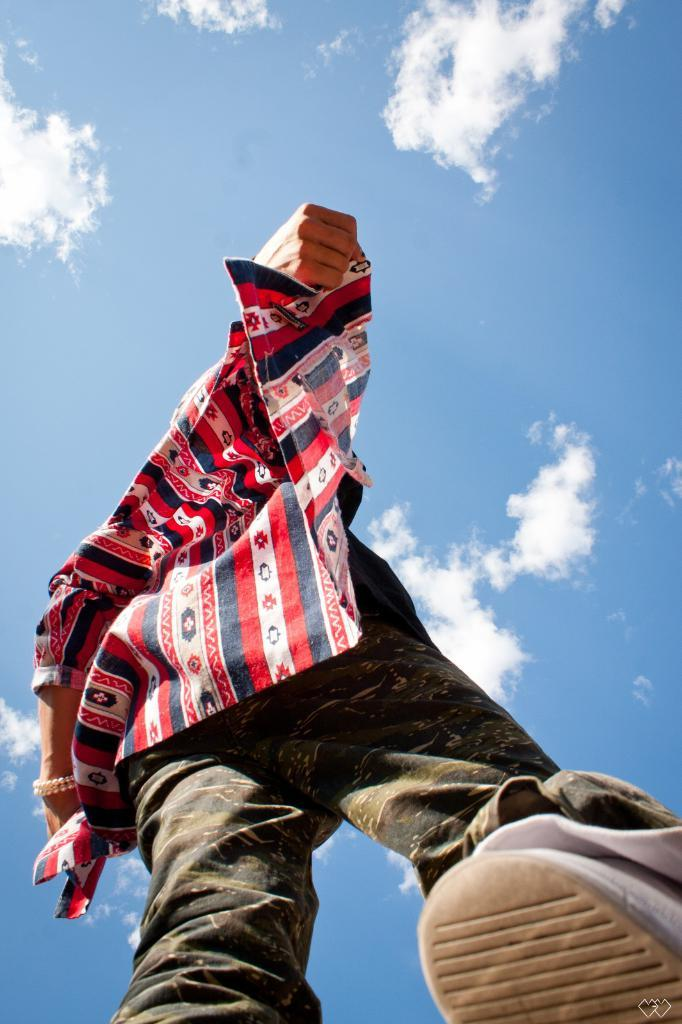Who or what is the main subject in the image? There is a person in the image. What is the person wearing? The person is wearing a shirt. What can be seen in the background of the image? There is sky visible in the background of the image. What is the condition of the sky in the image? Clouds are present in the sky. What type of bat can be seen flying in the image? There is no bat present in the image; it features a person and a sky with clouds. How many cows are visible in the image? There are no cows present in the image. 